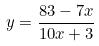Convert formula to latex. <formula><loc_0><loc_0><loc_500><loc_500>y = \frac { 8 3 - 7 x } { 1 0 x + 3 }</formula> 